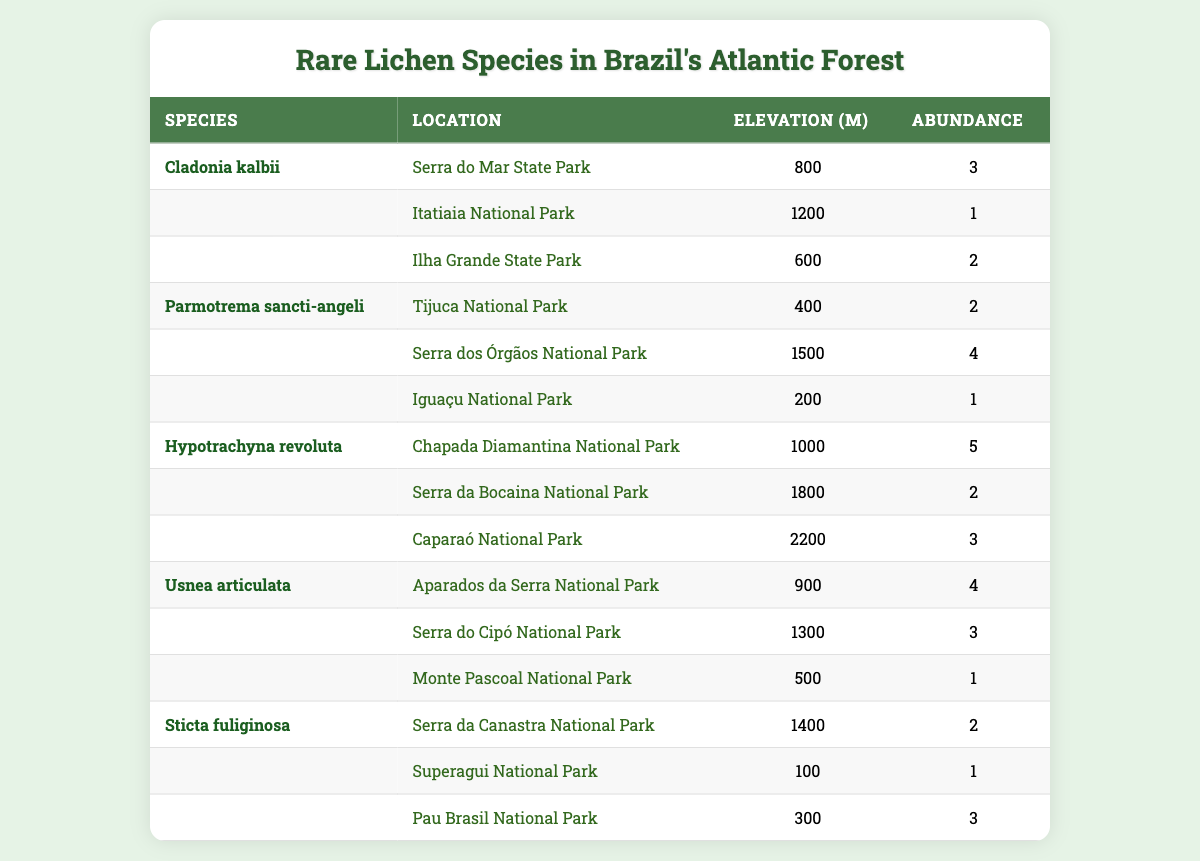What are the locations where *Cladonia kalbii* is found? The table lists the locations for *Cladonia kalbii* as "Serra do Mar State Park", "Itatiaia National Park", and "Ilha Grande State Park".
Answer: Serra do Mar State Park, Itatiaia National Park, Ilha Grande State Park What is the highest elevation at which *Usnea articulata* is found? The elevations for *Usnea articulata* are 900, 1300, and 500 meters. The highest value among these is 1300 meters.
Answer: 1300 meters How many total locations are listed for all lichen species combined? Each species has 3 locations, and there are 5 species, so the total number of locations is 5 species * 3 locations = 15 locations.
Answer: 15 locations Is the abundance of *Hypotrachyna revoluta* consistently higher than 2 across all its locations? The abundances for *Hypotrachyna revoluta* are 5, 2, and 3. Since 2 is not higher than 2, the statement is false.
Answer: No Which lichen species has the highest total abundance? The total abundances are calculated as follows: *Cladonia kalbii*: 3+1+2=6; *Parmotrema sancti-angeli*: 2+4+1=7; *Hypotrachyna revoluta*: 5+2+3=10; *Usnea articulata*: 4+3+1=8; *Sticta fuliginosa*: 2+1+3=6. The species with the highest total abundance is *Hypotrachyna revoluta* with 10.
Answer: Hypotrachyna revoluta Which species can be found in the highest elevation location? The species found at the highest elevation of 2200 meters is *Hypotrachyna revoluta* (Caparaó National Park).
Answer: Hypotrachyna revoluta What is the average abundance for *Sticta fuliginosa*? The abundances for *Sticta fuliginosa* are 2, 1, and 3. The sum is 2 + 1 + 3 = 6, and dividing by 3 gives an average of 6 / 3 = 2.
Answer: 2 Are *Tijuca National Park* and *Superagui National Park* both locations for any of the lichen species? The table shows that *Tijuca National Park* is a location for *Parmotrema sancti-angeli* and *Superagui National Park* is a location for *Sticta fuliginosa*. Since both parks are mentioned under different species, the answer is yes.
Answer: Yes Which lichen species has its highest abundance located at *Ilha Grande State Park*? At *Ilha Grande State Park*, the only species is *Cladonia kalbii*, which has an abundance of 2. Therefore, this species has its highest abundance at this location.
Answer: Cladonia kalbii What is the difference in abundance between the most and least abundant species across all its locations? The species with the highest total abundance is *Hypotrachyna revoluta* with 10, and the species with the least is *Cladonia kalbii* and *Sticta fuliginosa* with both having 6. The difference is 10 - 6 = 4.
Answer: 4 Are there any lichen species found only in national parks with elevation above 1000 meters? The species found in national parks above 1000 meters include *Hypotrachyna revoluta* and *Usnea articulata*. For species that are found only in those parks and elevations, further analysis shows that both do meet this condition.
Answer: Yes 